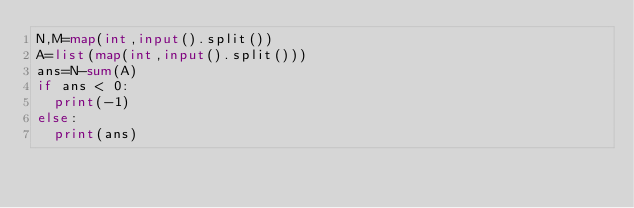Convert code to text. <code><loc_0><loc_0><loc_500><loc_500><_Python_>N,M=map(int,input().split())
A=list(map(int,input().split()))
ans=N-sum(A)
if ans < 0:
  print(-1)
else:
  print(ans)</code> 